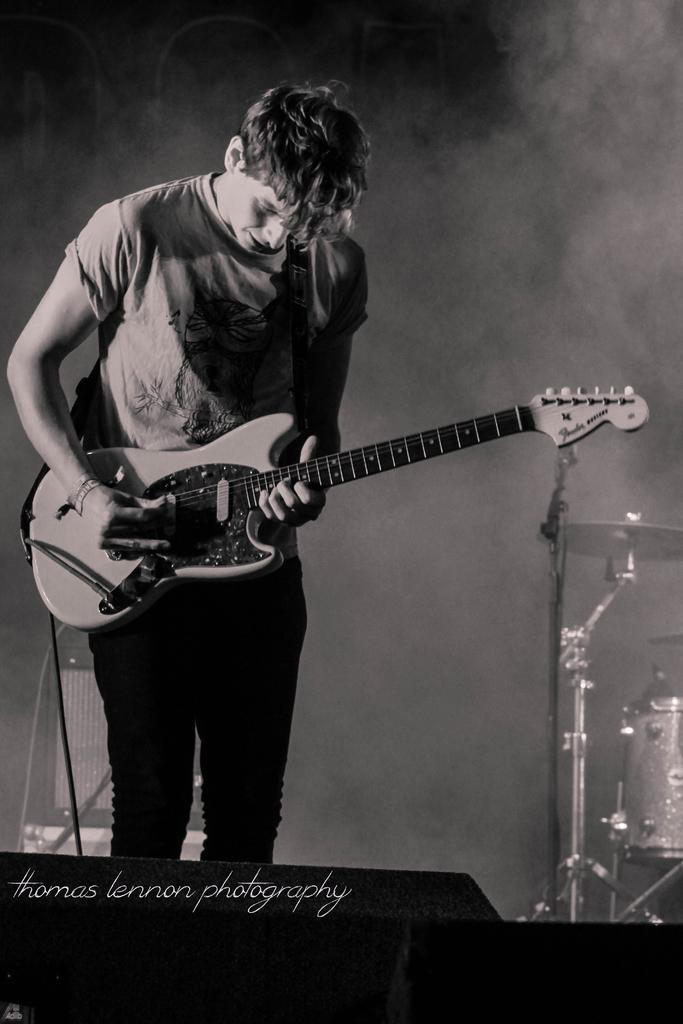Who is the person in the image? There is a man in the image. What is the man doing in the image? The man is playing a guitar. What other musical instrument is visible in the image? There is a drum beside the man. What is the purpose of the microphone in the image? The microphone is in front of the drum, likely for amplifying the sound of the drum. What type of oven is visible in the image? There is no oven present in the image. How many wires are connected to the man's knee in the image? There are no wires connected to the man's knee in the image. 